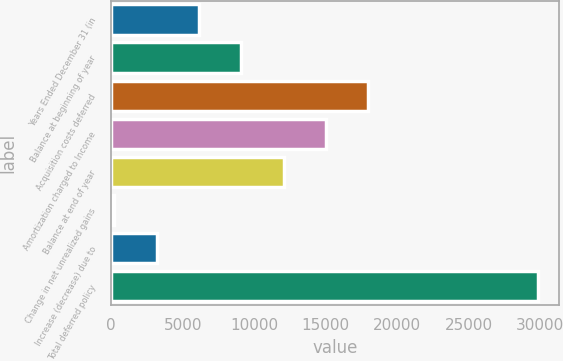Convert chart to OTSL. <chart><loc_0><loc_0><loc_500><loc_500><bar_chart><fcel>Years Ended December 31 (in<fcel>Balance at beginning of year<fcel>Acquisition costs deferred<fcel>Amortization charged to Income<fcel>Balance at end of year<fcel>Change in net unrealized gains<fcel>Increase (decrease) due to<fcel>Total deferred policy<nl><fcel>6138.6<fcel>9098.4<fcel>17977.8<fcel>15018<fcel>12058.2<fcel>219<fcel>3178.8<fcel>29817<nl></chart> 